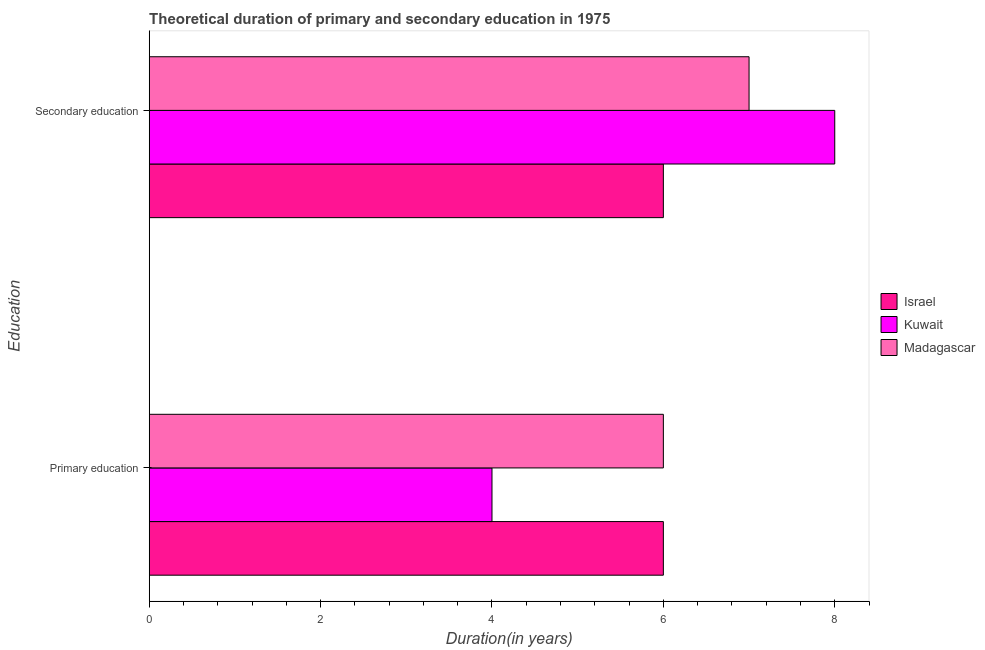How many different coloured bars are there?
Make the answer very short. 3. How many groups of bars are there?
Offer a terse response. 2. Are the number of bars per tick equal to the number of legend labels?
Provide a succinct answer. Yes. Are the number of bars on each tick of the Y-axis equal?
Your response must be concise. Yes. How many bars are there on the 1st tick from the top?
Your response must be concise. 3. How many bars are there on the 2nd tick from the bottom?
Provide a short and direct response. 3. What is the label of the 1st group of bars from the top?
Your answer should be very brief. Secondary education. What is the duration of primary education in Madagascar?
Ensure brevity in your answer.  6. Across all countries, what is the maximum duration of secondary education?
Make the answer very short. 8. Across all countries, what is the minimum duration of primary education?
Provide a succinct answer. 4. In which country was the duration of secondary education maximum?
Your answer should be compact. Kuwait. In which country was the duration of primary education minimum?
Your answer should be compact. Kuwait. What is the total duration of secondary education in the graph?
Your response must be concise. 21. What is the difference between the duration of primary education in Kuwait and that in Madagascar?
Provide a short and direct response. -2. What is the difference between the duration of primary education in Israel and the duration of secondary education in Madagascar?
Your response must be concise. -1. What is the average duration of primary education per country?
Keep it short and to the point. 5.33. What is the difference between the duration of primary education and duration of secondary education in Kuwait?
Provide a succinct answer. -4. In how many countries, is the duration of secondary education greater than 7.6 years?
Offer a terse response. 1. What is the ratio of the duration of primary education in Kuwait to that in Israel?
Give a very brief answer. 0.67. Is the duration of primary education in Israel less than that in Madagascar?
Your response must be concise. No. What does the 2nd bar from the top in Primary education represents?
Offer a very short reply. Kuwait. What does the 3rd bar from the bottom in Primary education represents?
Provide a short and direct response. Madagascar. Are all the bars in the graph horizontal?
Give a very brief answer. Yes. What is the difference between two consecutive major ticks on the X-axis?
Make the answer very short. 2. Are the values on the major ticks of X-axis written in scientific E-notation?
Offer a very short reply. No. Does the graph contain any zero values?
Make the answer very short. No. Does the graph contain grids?
Your response must be concise. No. Where does the legend appear in the graph?
Make the answer very short. Center right. How many legend labels are there?
Make the answer very short. 3. How are the legend labels stacked?
Your answer should be compact. Vertical. What is the title of the graph?
Your answer should be compact. Theoretical duration of primary and secondary education in 1975. Does "Bahamas" appear as one of the legend labels in the graph?
Offer a very short reply. No. What is the label or title of the X-axis?
Make the answer very short. Duration(in years). What is the label or title of the Y-axis?
Your answer should be compact. Education. What is the Duration(in years) in Madagascar in Primary education?
Provide a succinct answer. 6. What is the Duration(in years) in Kuwait in Secondary education?
Make the answer very short. 8. What is the Duration(in years) in Madagascar in Secondary education?
Your response must be concise. 7. Across all Education, what is the maximum Duration(in years) of Kuwait?
Give a very brief answer. 8. Across all Education, what is the maximum Duration(in years) in Madagascar?
Your answer should be very brief. 7. Across all Education, what is the minimum Duration(in years) of Israel?
Provide a succinct answer. 6. Across all Education, what is the minimum Duration(in years) in Madagascar?
Make the answer very short. 6. What is the total Duration(in years) in Israel in the graph?
Make the answer very short. 12. What is the total Duration(in years) of Madagascar in the graph?
Give a very brief answer. 13. What is the difference between the Duration(in years) of Madagascar in Primary education and that in Secondary education?
Ensure brevity in your answer.  -1. What is the difference between the Duration(in years) of Israel in Primary education and the Duration(in years) of Kuwait in Secondary education?
Your answer should be very brief. -2. What is the difference between the Duration(in years) of Israel in Primary education and the Duration(in years) of Madagascar in Secondary education?
Your answer should be very brief. -1. What is the average Duration(in years) in Madagascar per Education?
Your answer should be very brief. 6.5. What is the difference between the Duration(in years) in Israel and Duration(in years) in Madagascar in Primary education?
Give a very brief answer. 0. What is the difference between the Duration(in years) of Kuwait and Duration(in years) of Madagascar in Primary education?
Offer a terse response. -2. What is the difference between the Duration(in years) in Kuwait and Duration(in years) in Madagascar in Secondary education?
Give a very brief answer. 1. What is the ratio of the Duration(in years) in Israel in Primary education to that in Secondary education?
Give a very brief answer. 1. What is the ratio of the Duration(in years) in Madagascar in Primary education to that in Secondary education?
Give a very brief answer. 0.86. What is the difference between the highest and the second highest Duration(in years) in Israel?
Keep it short and to the point. 0. What is the difference between the highest and the lowest Duration(in years) of Israel?
Offer a terse response. 0. 